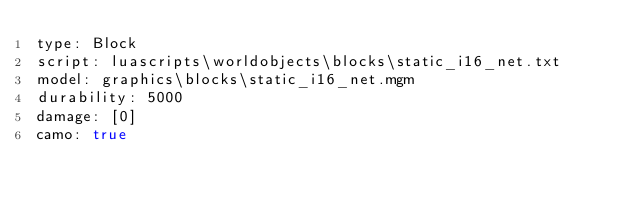Convert code to text. <code><loc_0><loc_0><loc_500><loc_500><_YAML_>type: Block
script: luascripts\worldobjects\blocks\static_i16_net.txt
model: graphics\blocks\static_i16_net.mgm
durability: 5000
damage: [0]
camo: true
</code> 